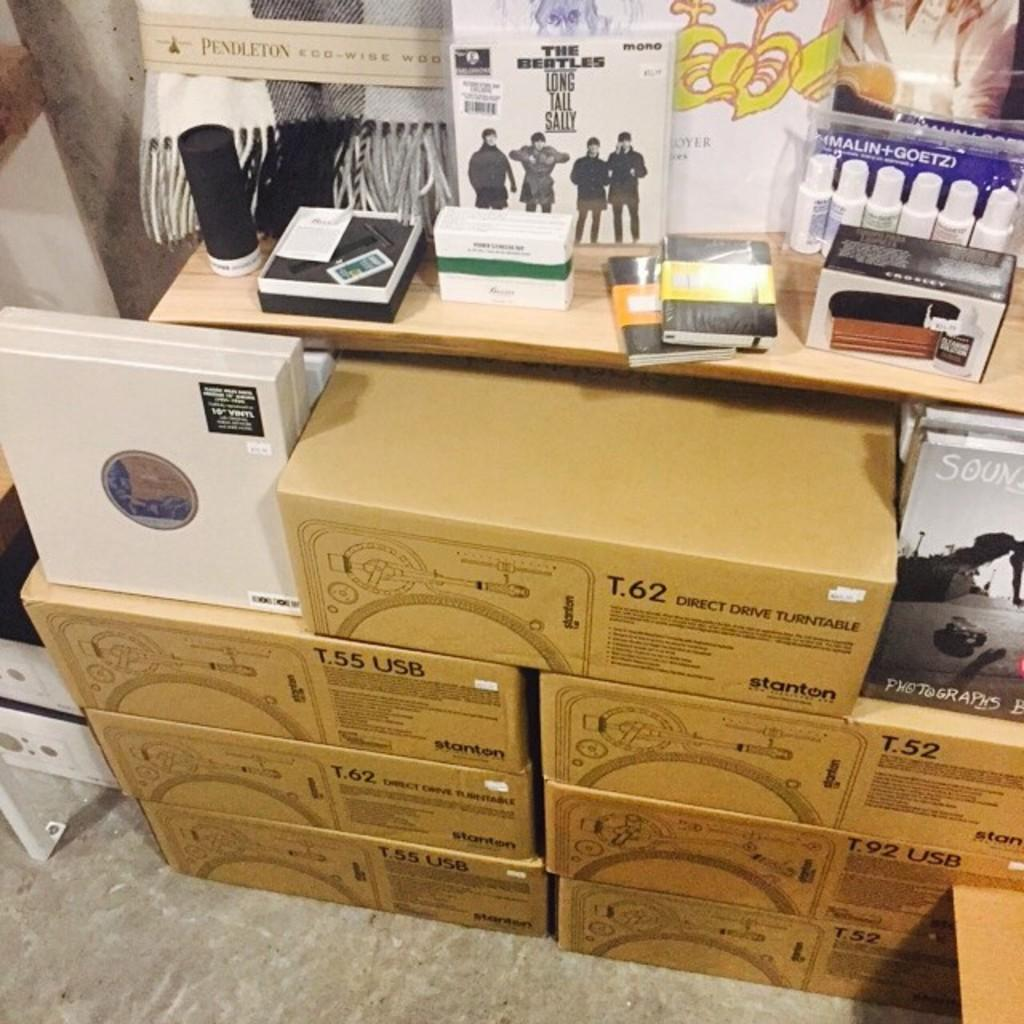What type of objects are made of cardboard in the image? There are cardboard boxes in the image. What type of objects can be seen in the image that are typically used for holding liquids? There are bottles in the image. What type of objects can be seen in the image that are typically used for reading and learning? There are books in the image. What type of object can be seen in the image that is used for storing or organizing items? There is a box in the image. What type of plant is being taught to stretch in the image? There is no plant or teaching activity present in the image. 